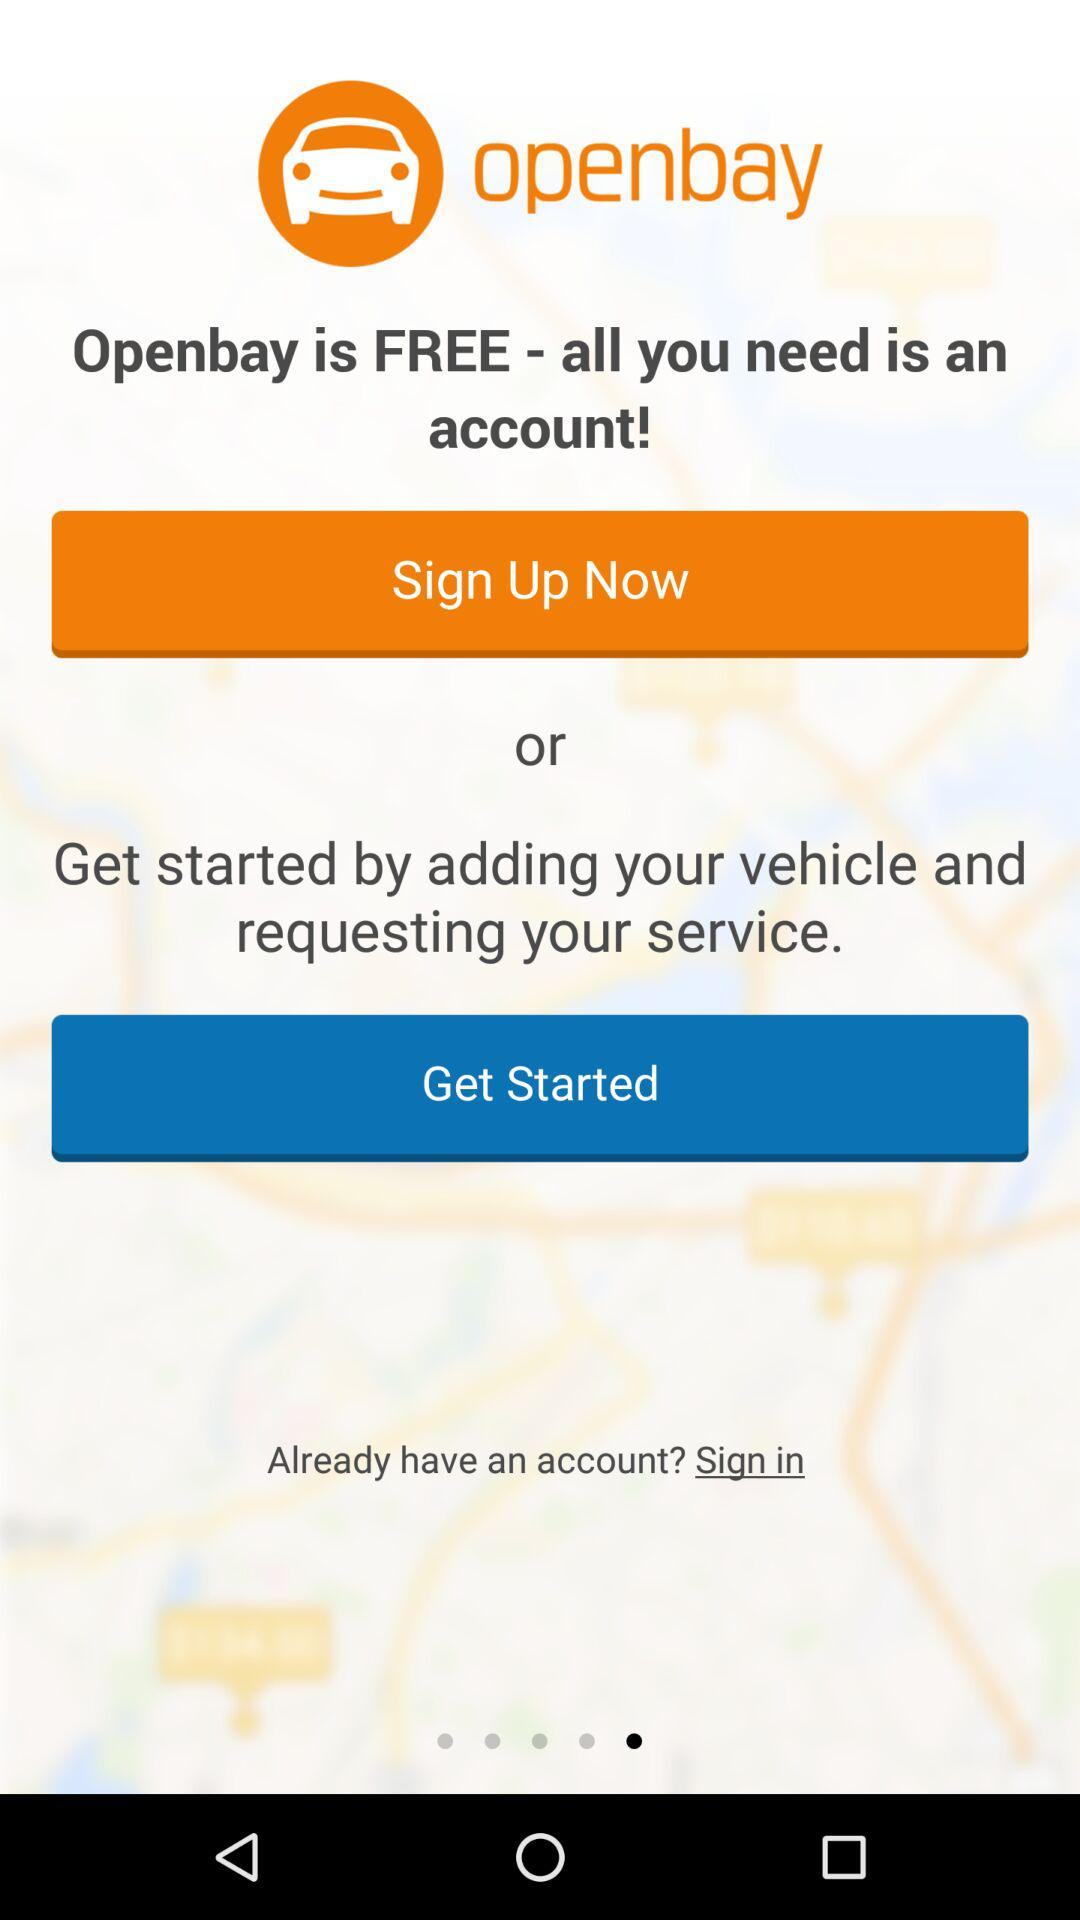How many options to use it?
When the provided information is insufficient, respond with <no answer>. <no answer> 